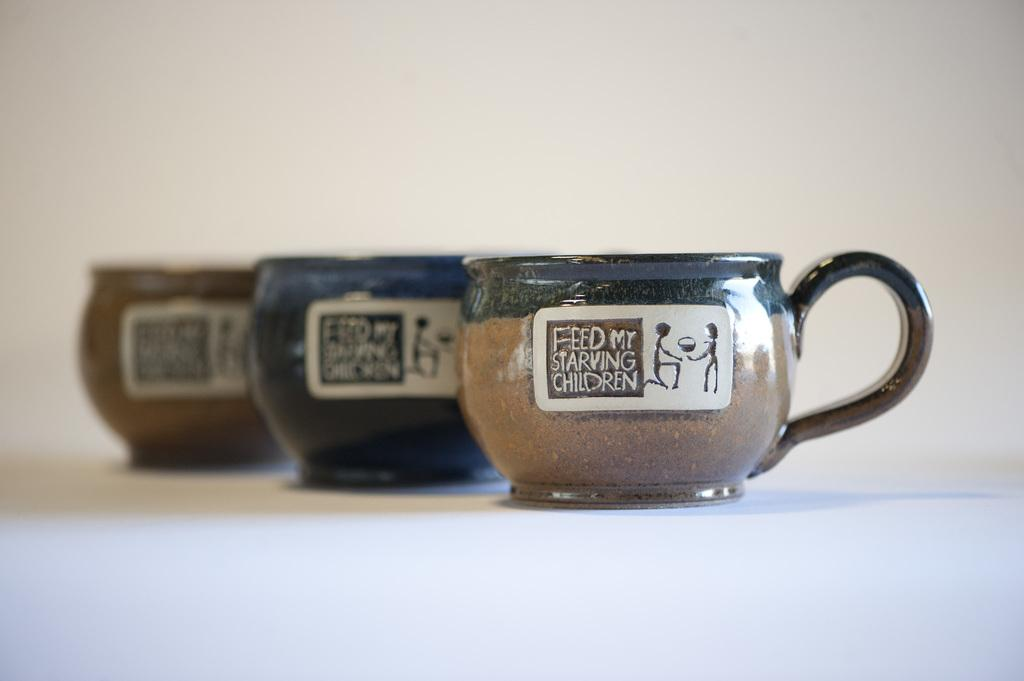How many cups are visible in the image? There are three cups in the image. What is the color of the surface on which the cups are placed? The cups are on a white surface. What is the price of the oil in the image? There is no oil present in the image, so it is not possible to determine its price. 